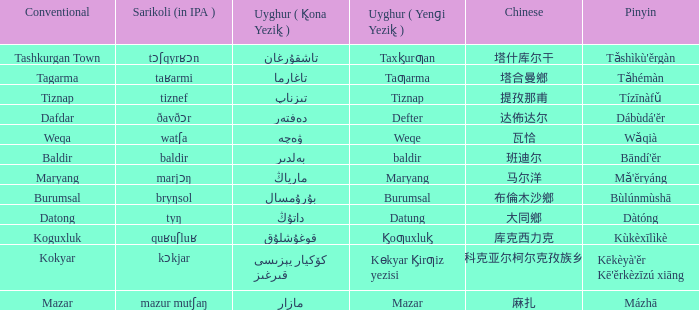Name the conventional for تاغارما Tagarma. Can you give me this table as a dict? {'header': ['Conventional', 'Sarikoli (in IPA )', 'Uyghur ( K̢ona Yezik̢ )', 'Uyghur ( Yenɡi Yezik̢ )', 'Chinese', 'Pinyin'], 'rows': [['Tashkurgan Town', 'tɔʃqyrʁɔn', 'تاشقۇرغان', 'Taxk̡urƣan', '塔什库尔干', "Tǎshìkù'ěrgàn"], ['Tagarma', 'taʁarmi', 'تاغارما', 'Taƣarma', '塔合曼鄉', 'Tǎhémàn'], ['Tiznap', 'tiznef', 'تىزناپ', 'Tiznap', '提孜那甫', 'Tízīnàfǔ'], ['Dafdar', 'ðavðɔr', 'دەفتەر', 'Defter', '达佈达尔', "Dábùdá'ĕr"], ['Weqa', 'watʃa', 'ۋەچە', 'Weqe', '瓦恰', 'Wǎqià'], ['Baldir', 'baldir', 'بەلدىر', 'baldir', '班迪尔', "Bāndí'ĕr"], ['Maryang', 'marjɔŋ', 'مارياڭ', 'Maryang', '马尔洋', "Mǎ'ĕryáng"], ['Burumsal', 'bryŋsol', 'بۇرۇمسال', 'Burumsal', '布倫木沙鄉', 'Bùlúnmùshā'], ['Datong', 'tyŋ', 'داتۇڭ', 'Datung', '大同鄉', 'Dàtóng'], ['Koguxluk', 'quʁuʃluʁ', 'قوغۇشلۇق', 'K̡oƣuxluk̡', '库克西力克', 'Kùkèxīlìkè'], ['Kokyar', 'kɔkjar', 'كۆكيار قىرغىز يېزىسى', 'Kɵkyar K̡irƣiz yezisi', '科克亚尔柯尔克孜族乡', "Kēkèyà'ěr Kē'ěrkèzīzú xiāng"], ['Mazar', 'mazur mutʃaŋ', 'مازار', 'Mazar', '麻扎', 'Mázhā']]} 